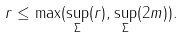Convert formula to latex. <formula><loc_0><loc_0><loc_500><loc_500>r \leq \max ( \sup _ { \Sigma } ( r ) , \sup _ { \Sigma } ( 2 m ) ) .</formula> 